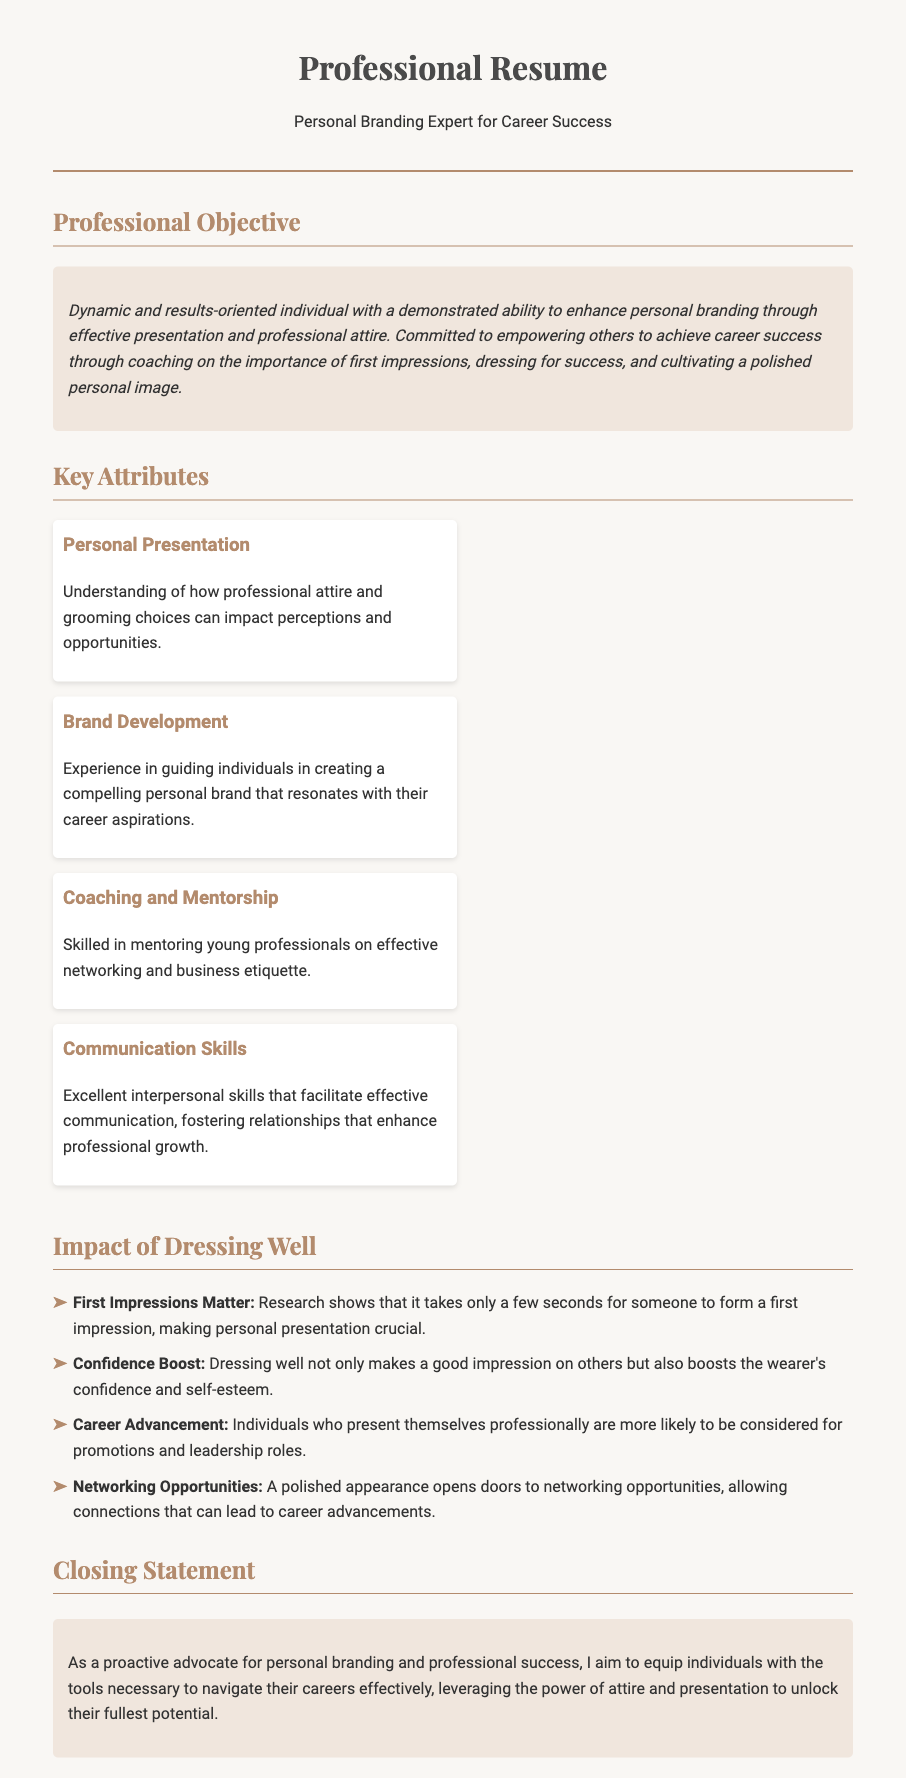What is the professional objective? The professional objective is a statement detailing the individual's commitment to enhancing personal branding and empowering others.
Answer: Dynamic and results-oriented individual with a demonstrated ability to enhance personal branding through effective presentation and professional attire What key attribute relates to communication? This attribute emphasizes the individual’s skills in conveying messages effectively and fostering growth.
Answer: Communication Skills How many impact statements are provided? The document lists four key impacts related to dressing well.
Answer: 4 What does the objective state about first impressions? The objective emphasizes the importance of first impressions in career success.
Answer: Importance of first impressions Which section discusses the benefits of personal presentation? The section outlines the positive effects of dressing well on confidence, career advancement, and networking opportunities.
Answer: Impact of Dressing Well What is one of the attributes related to mentoring? This attribute highlights the ability to guide and mentor others in professional development.
Answer: Coaching and Mentorship 